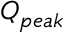Convert formula to latex. <formula><loc_0><loc_0><loc_500><loc_500>Q _ { p e a k }</formula> 